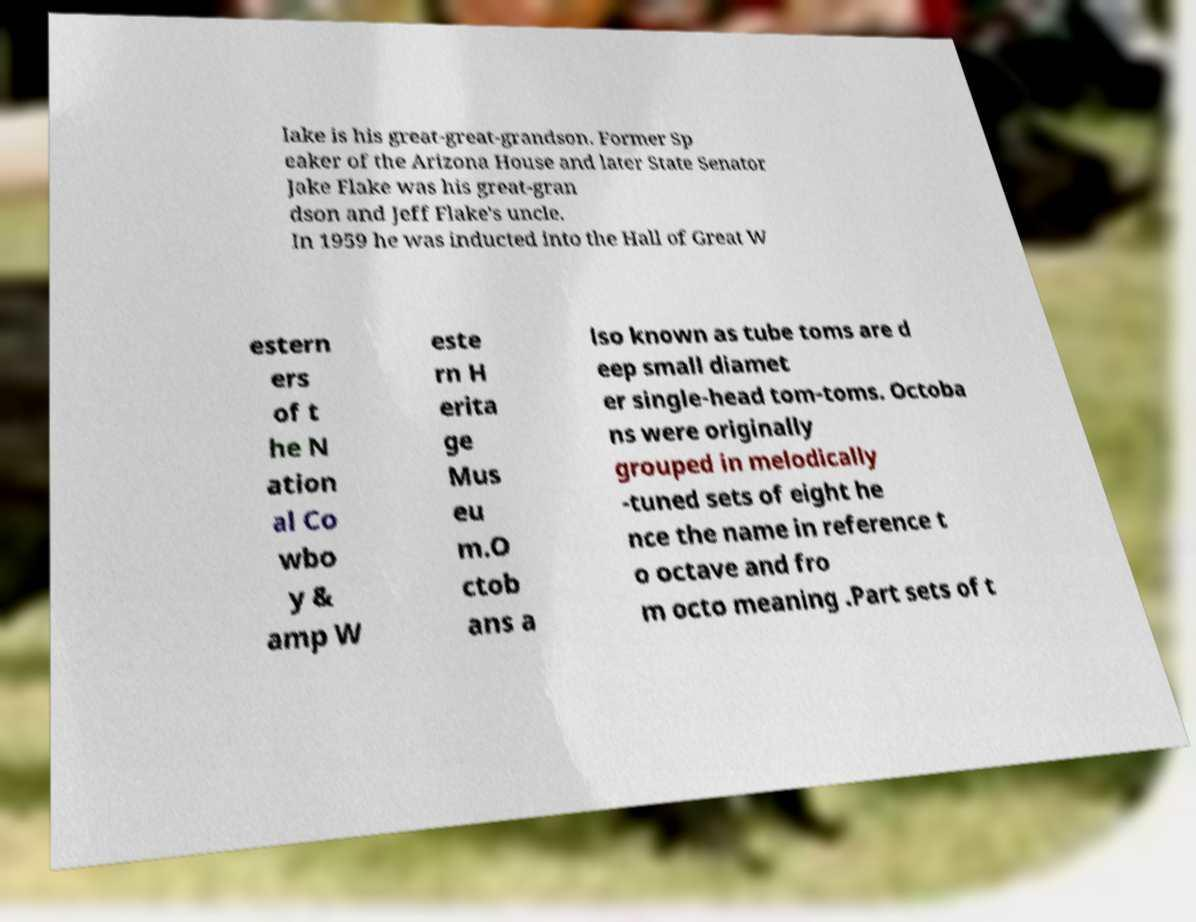Could you assist in decoding the text presented in this image and type it out clearly? lake is his great-great-grandson. Former Sp eaker of the Arizona House and later State Senator Jake Flake was his great-gran dson and Jeff Flake's uncle. In 1959 he was inducted into the Hall of Great W estern ers of t he N ation al Co wbo y & amp W este rn H erita ge Mus eu m.O ctob ans a lso known as tube toms are d eep small diamet er single-head tom-toms. Octoba ns were originally grouped in melodically -tuned sets of eight he nce the name in reference t o octave and fro m octo meaning .Part sets of t 